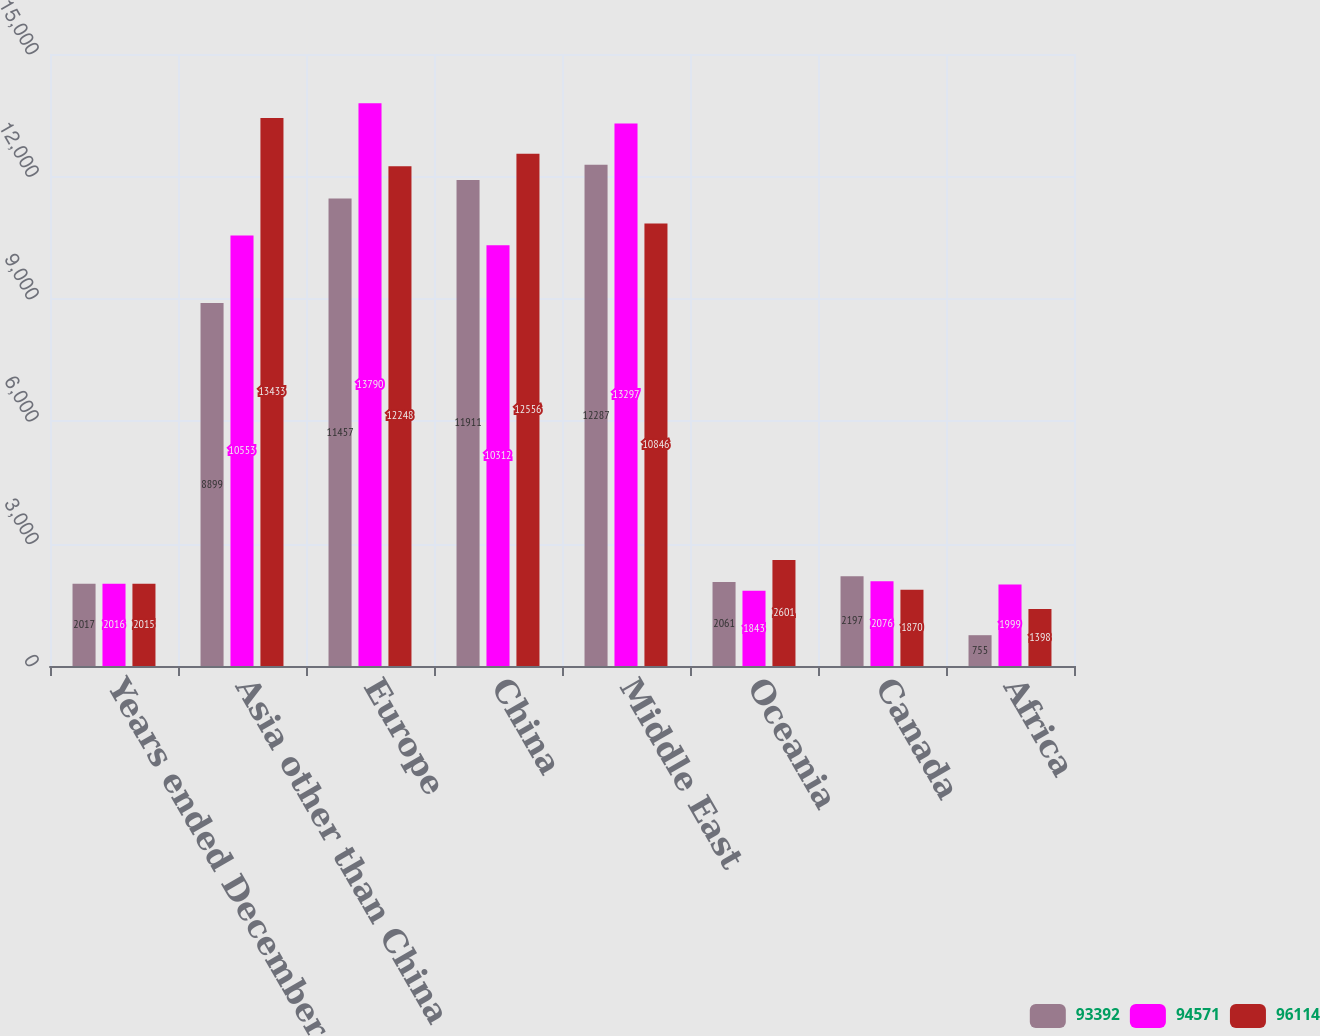<chart> <loc_0><loc_0><loc_500><loc_500><stacked_bar_chart><ecel><fcel>Years ended December 31<fcel>Asia other than China<fcel>Europe<fcel>China<fcel>Middle East<fcel>Oceania<fcel>Canada<fcel>Africa<nl><fcel>93392<fcel>2017<fcel>8899<fcel>11457<fcel>11911<fcel>12287<fcel>2061<fcel>2197<fcel>755<nl><fcel>94571<fcel>2016<fcel>10553<fcel>13790<fcel>10312<fcel>13297<fcel>1843<fcel>2076<fcel>1999<nl><fcel>96114<fcel>2015<fcel>13433<fcel>12248<fcel>12556<fcel>10846<fcel>2601<fcel>1870<fcel>1398<nl></chart> 